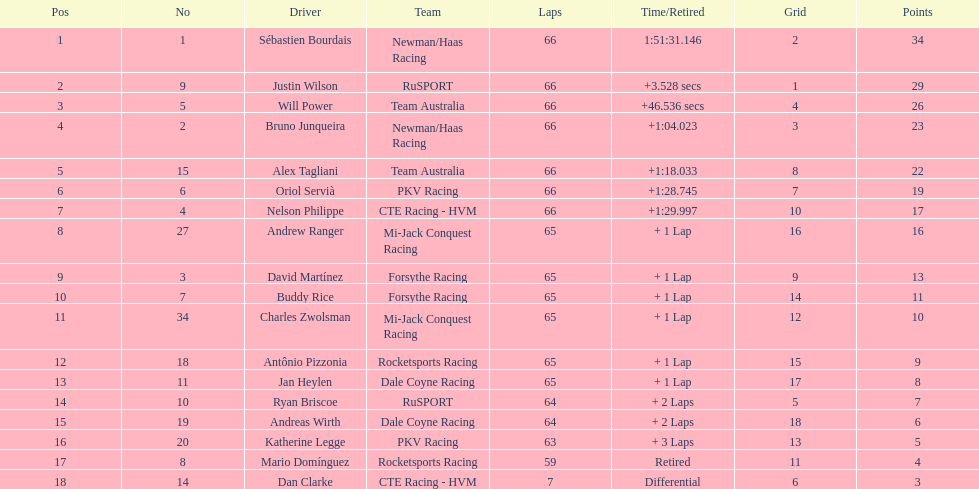How many laps did dan clarke finish? 7. 